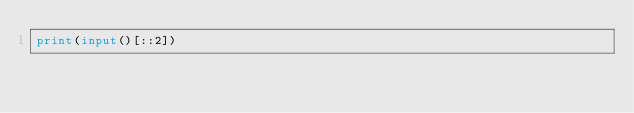<code> <loc_0><loc_0><loc_500><loc_500><_Python_>print(input()[::2])</code> 